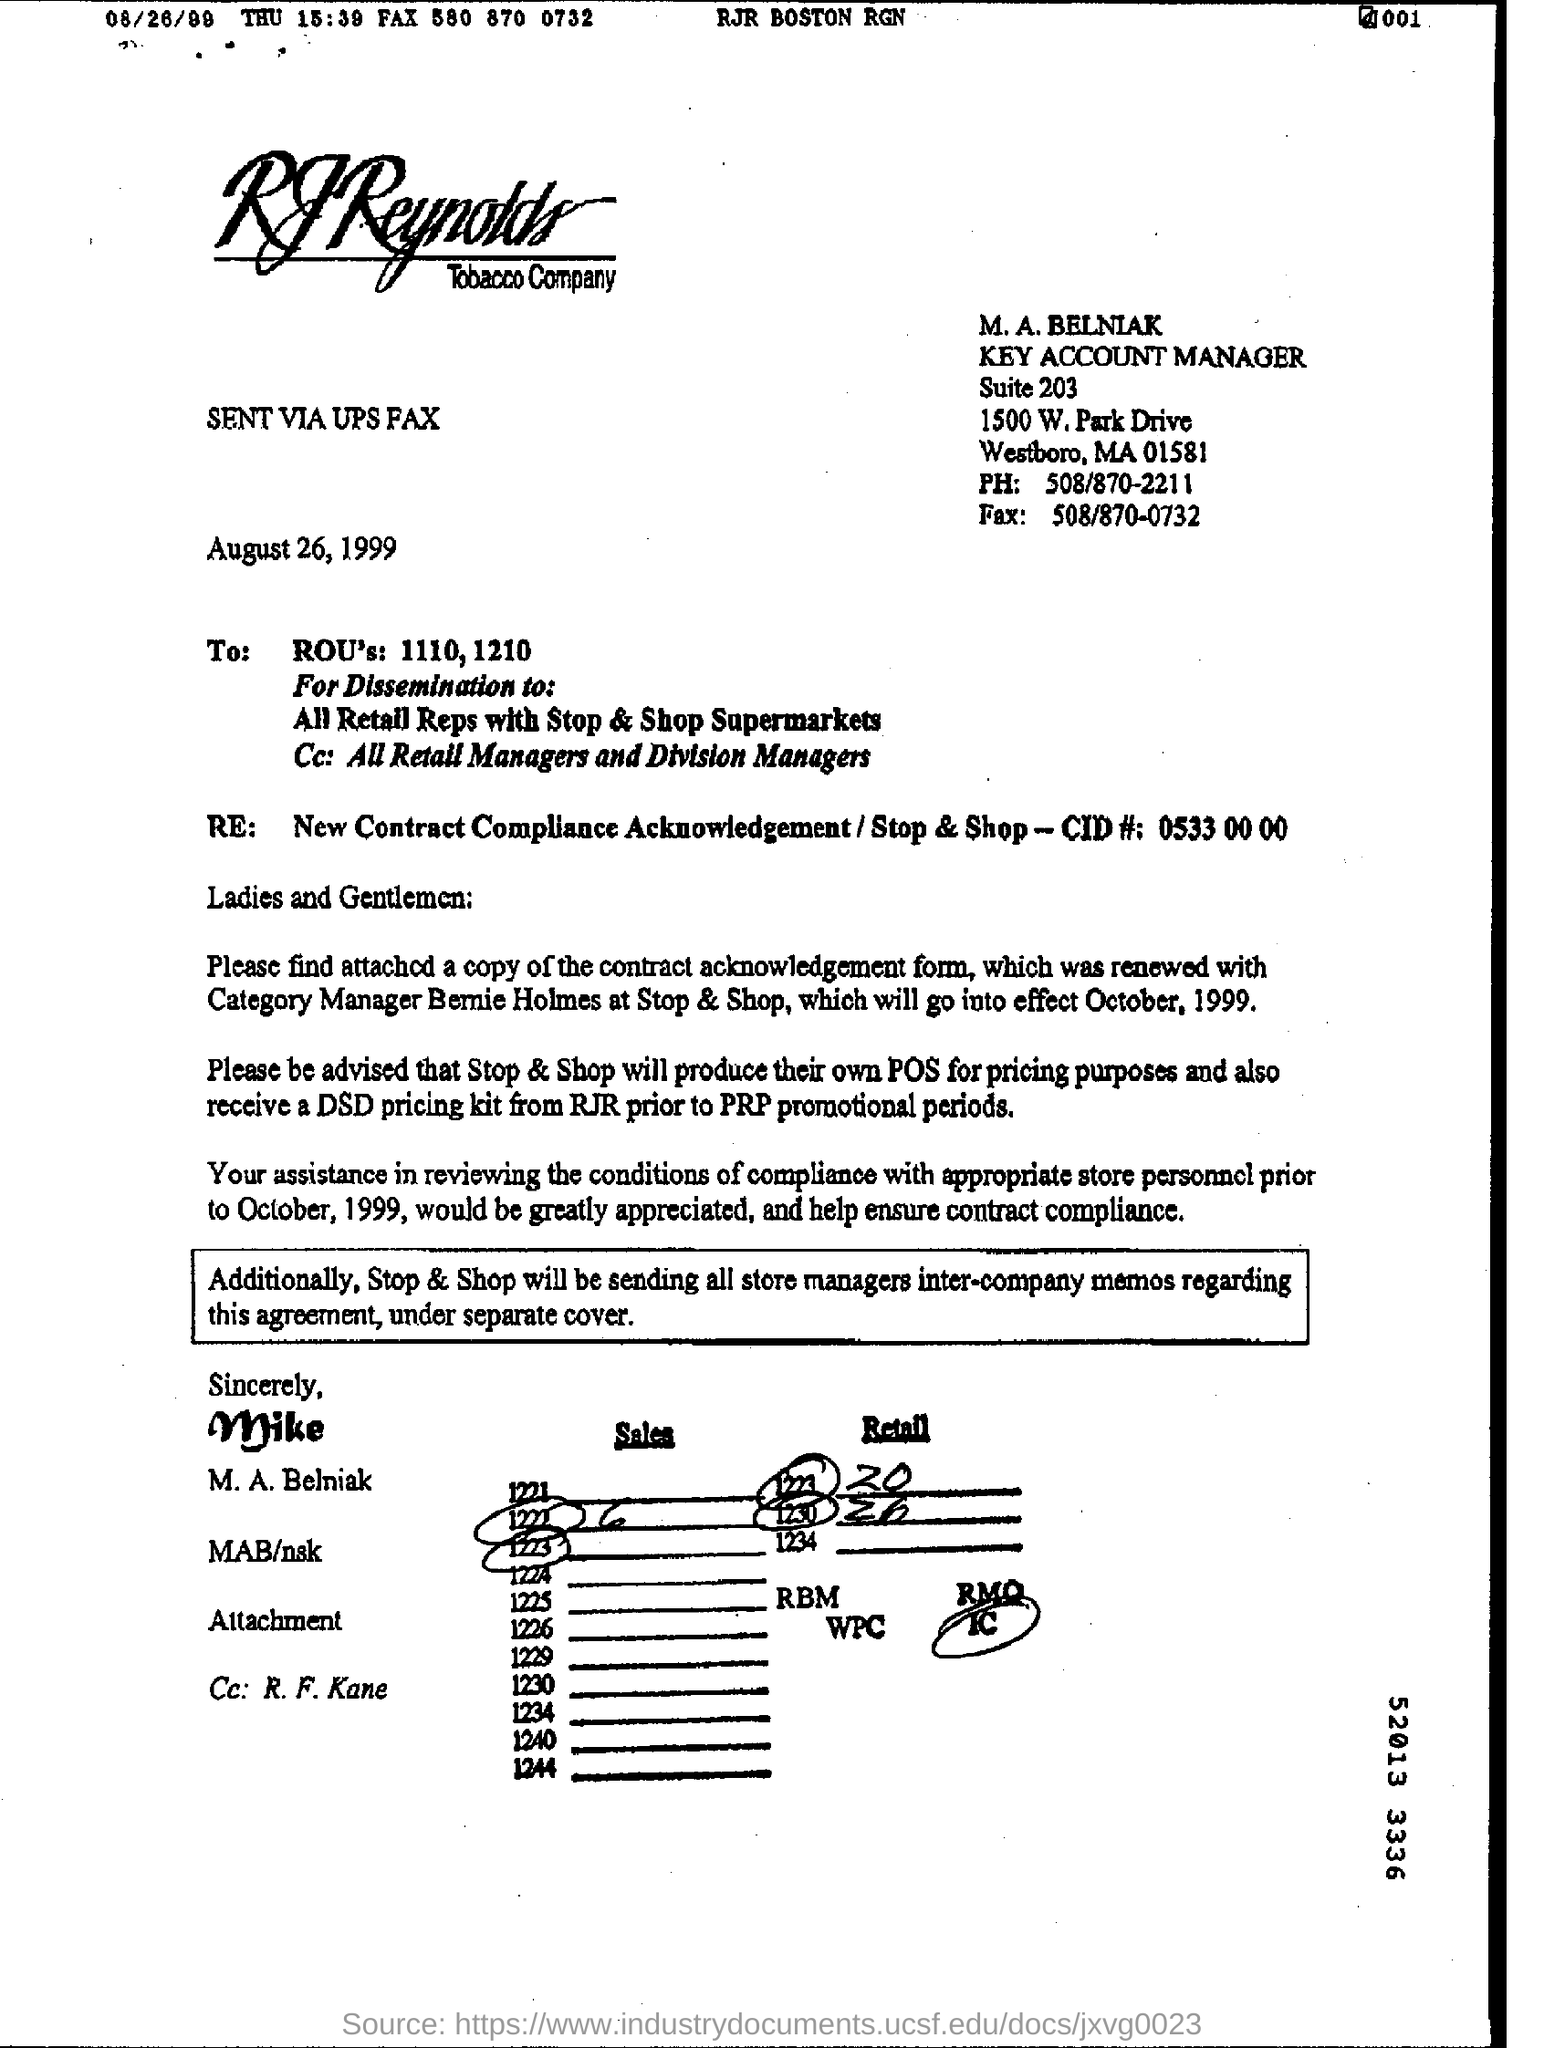What is the Company Name ?
Provide a short and direct response. R J Reynolds Tobacco Company. Who is the Key Account Manager ?
Provide a succinct answer. M. A. BELNIAK. What is the Suite Number ?
Provide a short and direct response. 203. What is the date of this communication?
Your answer should be very brief. August 26, 1999. What is the Fax Number ?
Make the answer very short. 508/870-0732. 